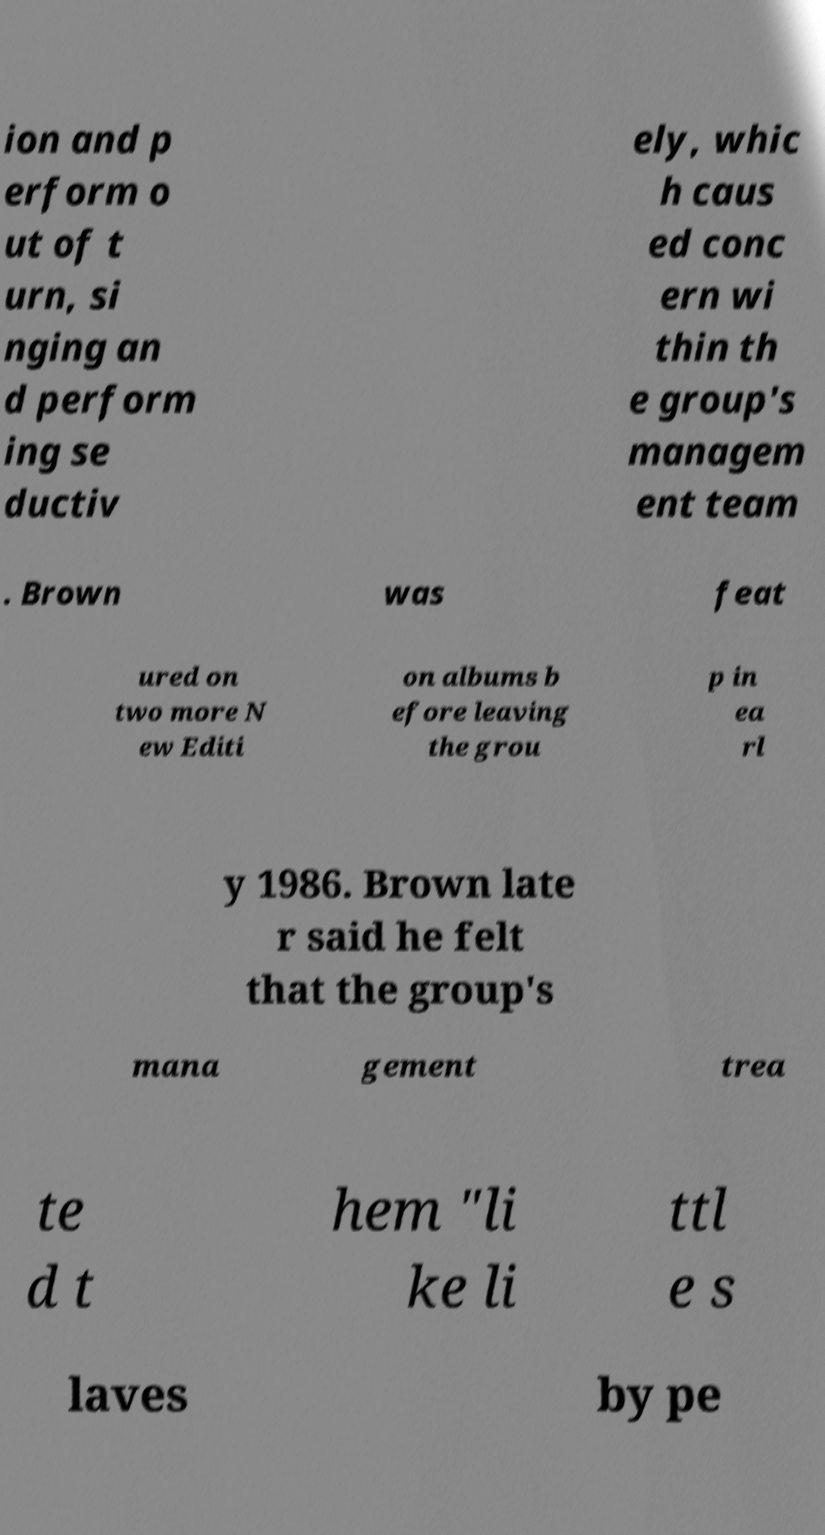What messages or text are displayed in this image? I need them in a readable, typed format. ion and p erform o ut of t urn, si nging an d perform ing se ductiv ely, whic h caus ed conc ern wi thin th e group's managem ent team . Brown was feat ured on two more N ew Editi on albums b efore leaving the grou p in ea rl y 1986. Brown late r said he felt that the group's mana gement trea te d t hem "li ke li ttl e s laves by pe 